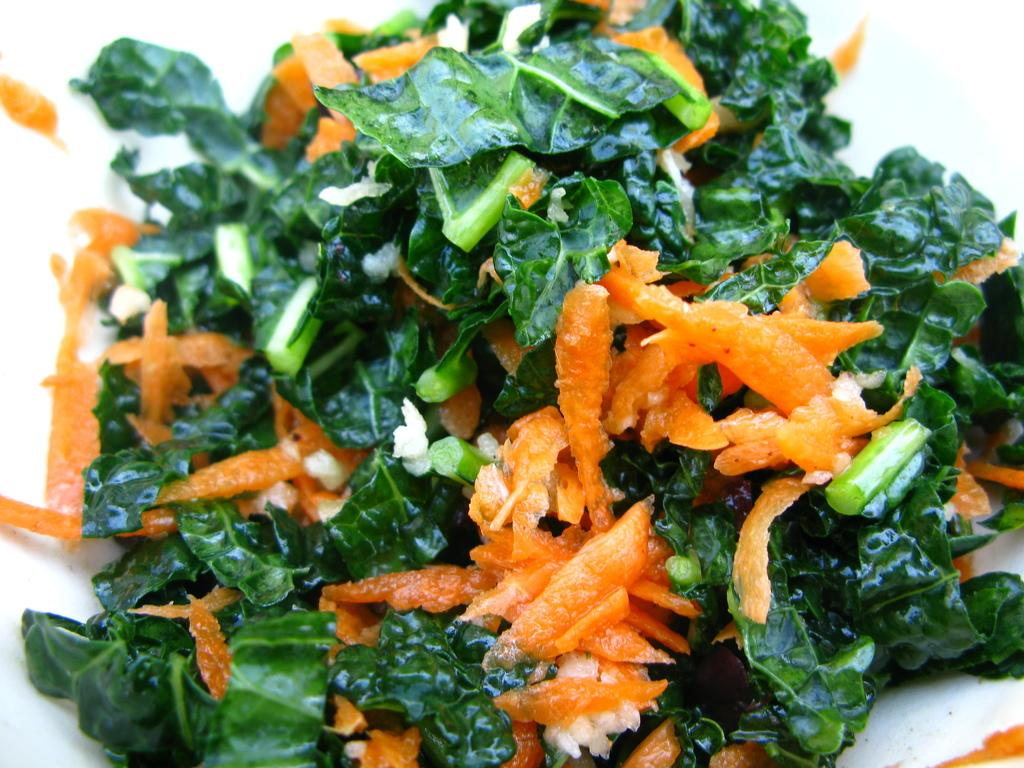What color are the pieces of food in the image? The pieces of food in the image are orange in color. What type of vegetation can be seen in the image? There are green leaves in the image. Where is the cobweb located in the image? There is no cobweb present in the image. What type of quiver can be seen in the image? There is no quiver present in the image. 